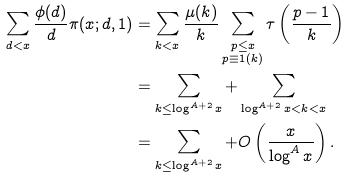<formula> <loc_0><loc_0><loc_500><loc_500>\sum _ { d < x } \frac { \phi ( d ) } d \pi ( x ; d , 1 ) & = \sum _ { k < x } \frac { \mu ( k ) } k \sum _ { \substack { { p \leq x } \\ { p \equiv 1 ( k ) } } } \tau \left ( \frac { p - 1 } k \right ) \\ & = \sum _ { k \leq \log ^ { A + 2 } x } + \sum _ { \log ^ { A + 2 } x < k < x } \\ & = \sum _ { k \leq \log ^ { A + 2 } x } + O \left ( \frac { x } { \log ^ { A } x } \right ) .</formula> 